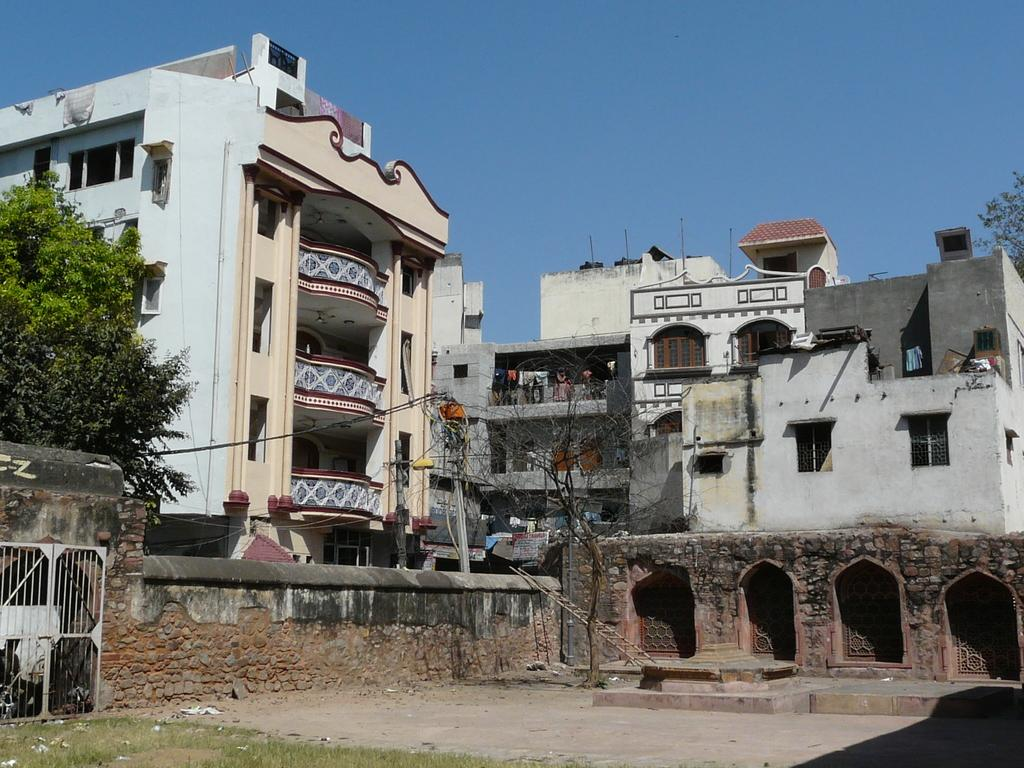What type of structures can be seen in the image? There are buildings in the image. What other natural elements are present in the image? There are trees in the image. What part of the natural environment is visible in the image? The sky is visible in the image. What type of gun is being used by the person in the image? There is no person or gun present in the image; it features buildings, trees, and the sky. 